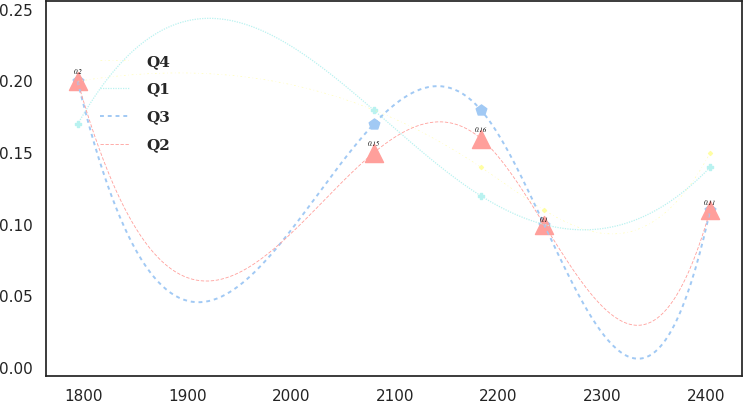<chart> <loc_0><loc_0><loc_500><loc_500><line_chart><ecel><fcel>Q4<fcel>Q1<fcel>Q3<fcel>Q2<nl><fcel>1794.16<fcel>0.2<fcel>0.17<fcel>0.2<fcel>0.2<nl><fcel>2079.58<fcel>0.18<fcel>0.18<fcel>0.17<fcel>0.15<nl><fcel>2183.07<fcel>0.14<fcel>0.12<fcel>0.18<fcel>0.16<nl><fcel>2244.07<fcel>0.11<fcel>0.1<fcel>0.1<fcel>0.1<nl><fcel>2404.16<fcel>0.15<fcel>0.14<fcel>0.11<fcel>0.11<nl></chart> 